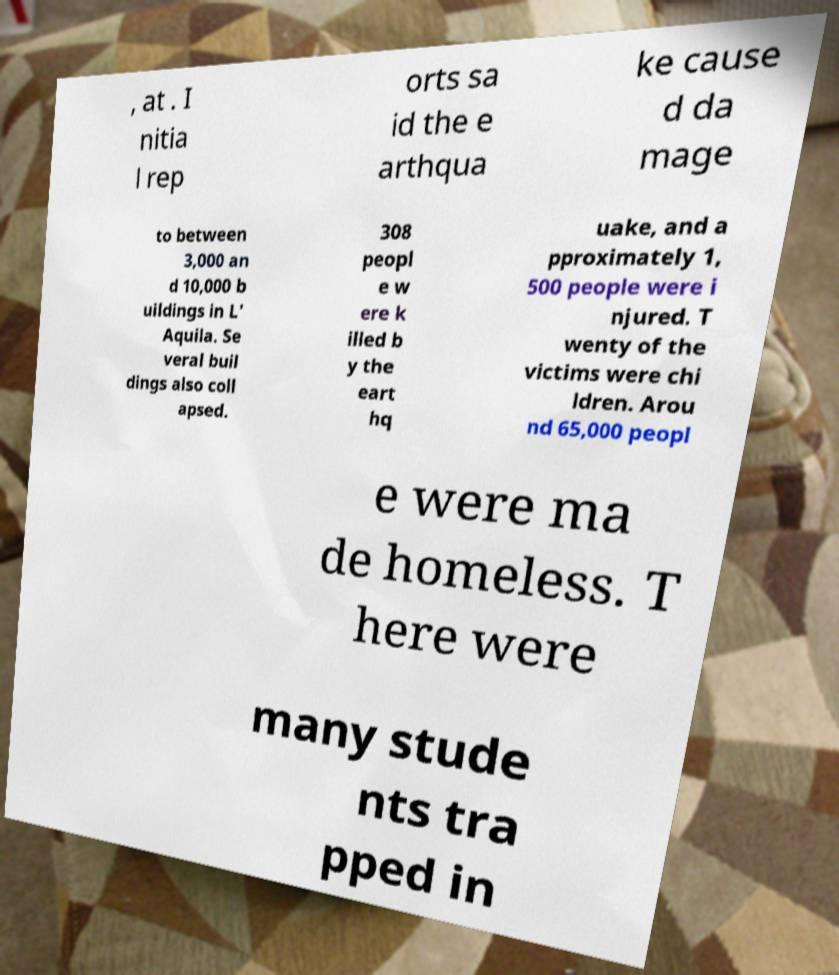There's text embedded in this image that I need extracted. Can you transcribe it verbatim? , at . I nitia l rep orts sa id the e arthqua ke cause d da mage to between 3,000 an d 10,000 b uildings in L' Aquila. Se veral buil dings also coll apsed. 308 peopl e w ere k illed b y the eart hq uake, and a pproximately 1, 500 people were i njured. T wenty of the victims were chi ldren. Arou nd 65,000 peopl e were ma de homeless. T here were many stude nts tra pped in 